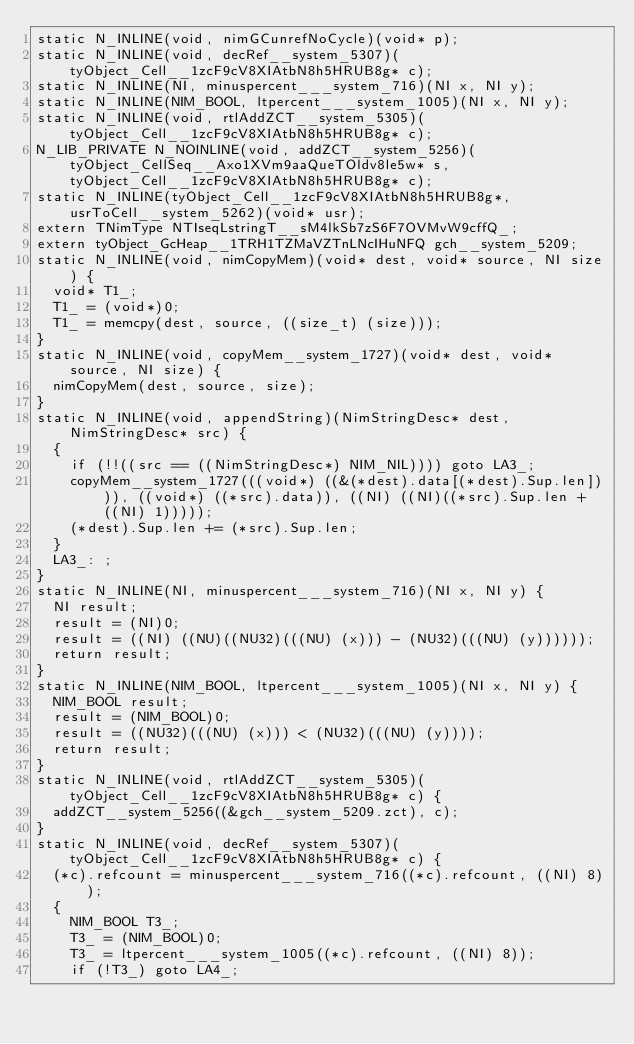Convert code to text. <code><loc_0><loc_0><loc_500><loc_500><_C_>static N_INLINE(void, nimGCunrefNoCycle)(void* p);
static N_INLINE(void, decRef__system_5307)(tyObject_Cell__1zcF9cV8XIAtbN8h5HRUB8g* c);
static N_INLINE(NI, minuspercent___system_716)(NI x, NI y);
static N_INLINE(NIM_BOOL, ltpercent___system_1005)(NI x, NI y);
static N_INLINE(void, rtlAddZCT__system_5305)(tyObject_Cell__1zcF9cV8XIAtbN8h5HRUB8g* c);
N_LIB_PRIVATE N_NOINLINE(void, addZCT__system_5256)(tyObject_CellSeq__Axo1XVm9aaQueTOldv8le5w* s, tyObject_Cell__1zcF9cV8XIAtbN8h5HRUB8g* c);
static N_INLINE(tyObject_Cell__1zcF9cV8XIAtbN8h5HRUB8g*, usrToCell__system_5262)(void* usr);
extern TNimType NTIseqLstringT__sM4lkSb7zS6F7OVMvW9cffQ_;
extern tyObject_GcHeap__1TRH1TZMaVZTnLNcIHuNFQ gch__system_5209;
static N_INLINE(void, nimCopyMem)(void* dest, void* source, NI size) {
	void* T1_;
	T1_ = (void*)0;
	T1_ = memcpy(dest, source, ((size_t) (size)));
}
static N_INLINE(void, copyMem__system_1727)(void* dest, void* source, NI size) {
	nimCopyMem(dest, source, size);
}
static N_INLINE(void, appendString)(NimStringDesc* dest, NimStringDesc* src) {
	{
		if (!!((src == ((NimStringDesc*) NIM_NIL)))) goto LA3_;
		copyMem__system_1727(((void*) ((&(*dest).data[(*dest).Sup.len]))), ((void*) ((*src).data)), ((NI) ((NI)((*src).Sup.len + ((NI) 1)))));
		(*dest).Sup.len += (*src).Sup.len;
	}
	LA3_: ;
}
static N_INLINE(NI, minuspercent___system_716)(NI x, NI y) {
	NI result;
	result = (NI)0;
	result = ((NI) ((NU)((NU32)(((NU) (x))) - (NU32)(((NU) (y))))));
	return result;
}
static N_INLINE(NIM_BOOL, ltpercent___system_1005)(NI x, NI y) {
	NIM_BOOL result;
	result = (NIM_BOOL)0;
	result = ((NU32)(((NU) (x))) < (NU32)(((NU) (y))));
	return result;
}
static N_INLINE(void, rtlAddZCT__system_5305)(tyObject_Cell__1zcF9cV8XIAtbN8h5HRUB8g* c) {
	addZCT__system_5256((&gch__system_5209.zct), c);
}
static N_INLINE(void, decRef__system_5307)(tyObject_Cell__1zcF9cV8XIAtbN8h5HRUB8g* c) {
	(*c).refcount = minuspercent___system_716((*c).refcount, ((NI) 8));
	{
		NIM_BOOL T3_;
		T3_ = (NIM_BOOL)0;
		T3_ = ltpercent___system_1005((*c).refcount, ((NI) 8));
		if (!T3_) goto LA4_;</code> 